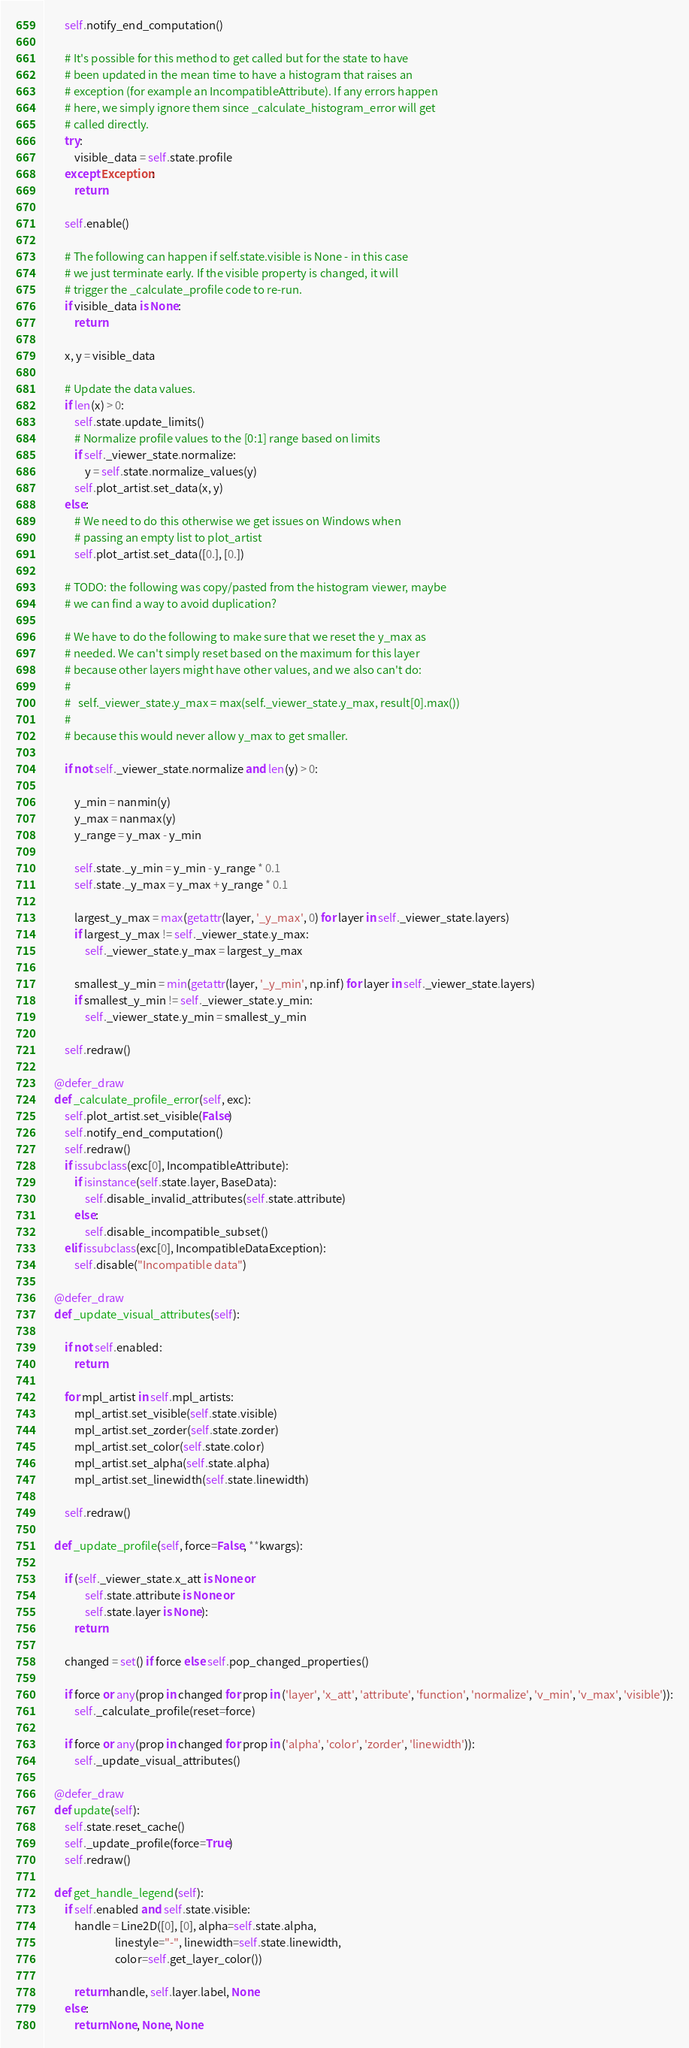<code> <loc_0><loc_0><loc_500><loc_500><_Python_>        self.notify_end_computation()

        # It's possible for this method to get called but for the state to have
        # been updated in the mean time to have a histogram that raises an
        # exception (for example an IncompatibleAttribute). If any errors happen
        # here, we simply ignore them since _calculate_histogram_error will get
        # called directly.
        try:
            visible_data = self.state.profile
        except Exception:
            return

        self.enable()

        # The following can happen if self.state.visible is None - in this case
        # we just terminate early. If the visible property is changed, it will
        # trigger the _calculate_profile code to re-run.
        if visible_data is None:
            return

        x, y = visible_data

        # Update the data values.
        if len(x) > 0:
            self.state.update_limits()
            # Normalize profile values to the [0:1] range based on limits
            if self._viewer_state.normalize:
                y = self.state.normalize_values(y)
            self.plot_artist.set_data(x, y)
        else:
            # We need to do this otherwise we get issues on Windows when
            # passing an empty list to plot_artist
            self.plot_artist.set_data([0.], [0.])

        # TODO: the following was copy/pasted from the histogram viewer, maybe
        # we can find a way to avoid duplication?

        # We have to do the following to make sure that we reset the y_max as
        # needed. We can't simply reset based on the maximum for this layer
        # because other layers might have other values, and we also can't do:
        #
        #   self._viewer_state.y_max = max(self._viewer_state.y_max, result[0].max())
        #
        # because this would never allow y_max to get smaller.

        if not self._viewer_state.normalize and len(y) > 0:

            y_min = nanmin(y)
            y_max = nanmax(y)
            y_range = y_max - y_min

            self.state._y_min = y_min - y_range * 0.1
            self.state._y_max = y_max + y_range * 0.1

            largest_y_max = max(getattr(layer, '_y_max', 0) for layer in self._viewer_state.layers)
            if largest_y_max != self._viewer_state.y_max:
                self._viewer_state.y_max = largest_y_max

            smallest_y_min = min(getattr(layer, '_y_min', np.inf) for layer in self._viewer_state.layers)
            if smallest_y_min != self._viewer_state.y_min:
                self._viewer_state.y_min = smallest_y_min

        self.redraw()

    @defer_draw
    def _calculate_profile_error(self, exc):
        self.plot_artist.set_visible(False)
        self.notify_end_computation()
        self.redraw()
        if issubclass(exc[0], IncompatibleAttribute):
            if isinstance(self.state.layer, BaseData):
                self.disable_invalid_attributes(self.state.attribute)
            else:
                self.disable_incompatible_subset()
        elif issubclass(exc[0], IncompatibleDataException):
            self.disable("Incompatible data")

    @defer_draw
    def _update_visual_attributes(self):

        if not self.enabled:
            return

        for mpl_artist in self.mpl_artists:
            mpl_artist.set_visible(self.state.visible)
            mpl_artist.set_zorder(self.state.zorder)
            mpl_artist.set_color(self.state.color)
            mpl_artist.set_alpha(self.state.alpha)
            mpl_artist.set_linewidth(self.state.linewidth)

        self.redraw()

    def _update_profile(self, force=False, **kwargs):

        if (self._viewer_state.x_att is None or
                self.state.attribute is None or
                self.state.layer is None):
            return

        changed = set() if force else self.pop_changed_properties()

        if force or any(prop in changed for prop in ('layer', 'x_att', 'attribute', 'function', 'normalize', 'v_min', 'v_max', 'visible')):
            self._calculate_profile(reset=force)

        if force or any(prop in changed for prop in ('alpha', 'color', 'zorder', 'linewidth')):
            self._update_visual_attributes()

    @defer_draw
    def update(self):
        self.state.reset_cache()
        self._update_profile(force=True)
        self.redraw()

    def get_handle_legend(self):
        if self.enabled and self.state.visible:
            handle = Line2D([0], [0], alpha=self.state.alpha,
                            linestyle="-", linewidth=self.state.linewidth,
                            color=self.get_layer_color())

            return handle, self.layer.label, None
        else:
            return None, None, None
</code> 